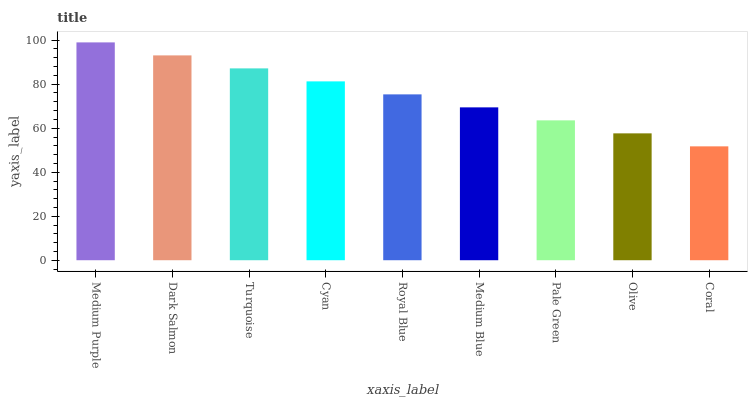Is Coral the minimum?
Answer yes or no. Yes. Is Medium Purple the maximum?
Answer yes or no. Yes. Is Dark Salmon the minimum?
Answer yes or no. No. Is Dark Salmon the maximum?
Answer yes or no. No. Is Medium Purple greater than Dark Salmon?
Answer yes or no. Yes. Is Dark Salmon less than Medium Purple?
Answer yes or no. Yes. Is Dark Salmon greater than Medium Purple?
Answer yes or no. No. Is Medium Purple less than Dark Salmon?
Answer yes or no. No. Is Royal Blue the high median?
Answer yes or no. Yes. Is Royal Blue the low median?
Answer yes or no. Yes. Is Cyan the high median?
Answer yes or no. No. Is Olive the low median?
Answer yes or no. No. 